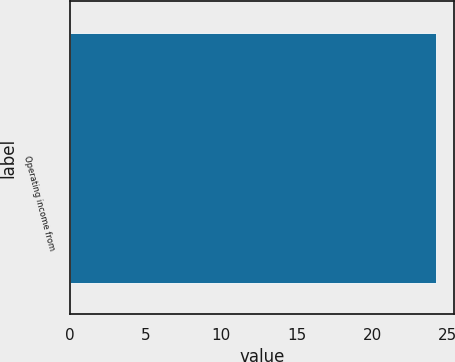<chart> <loc_0><loc_0><loc_500><loc_500><bar_chart><fcel>Operating income from<nl><fcel>24.2<nl></chart> 